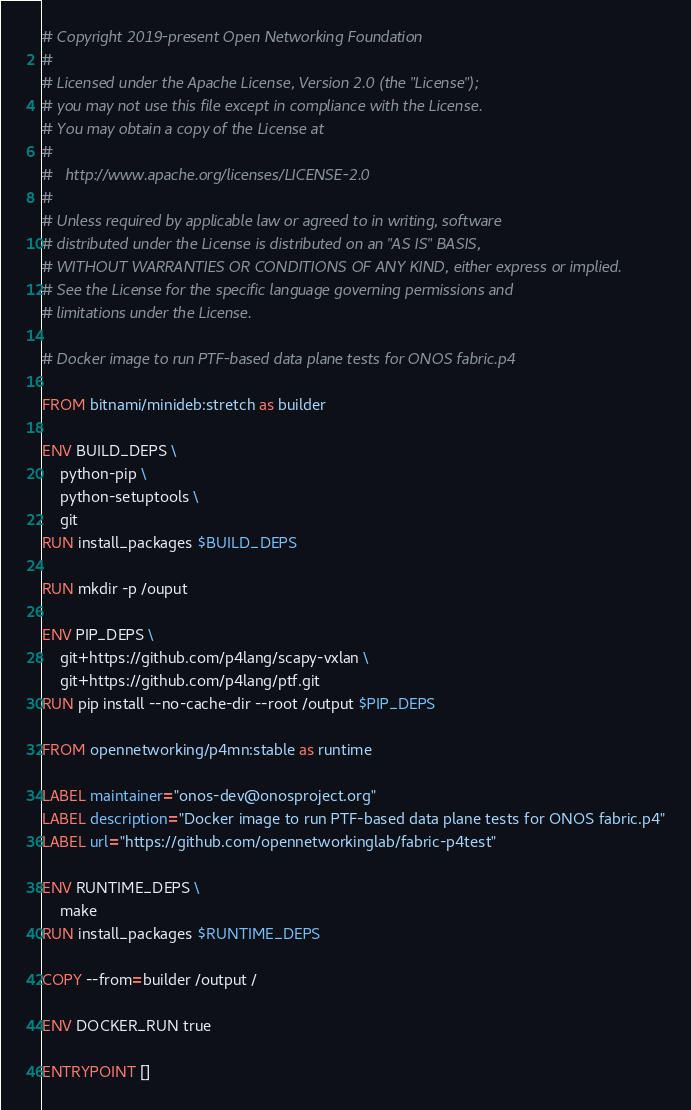Convert code to text. <code><loc_0><loc_0><loc_500><loc_500><_Dockerfile_># Copyright 2019-present Open Networking Foundation
#
# Licensed under the Apache License, Version 2.0 (the "License");
# you may not use this file except in compliance with the License.
# You may obtain a copy of the License at
#
#   http://www.apache.org/licenses/LICENSE-2.0
#
# Unless required by applicable law or agreed to in writing, software
# distributed under the License is distributed on an "AS IS" BASIS,
# WITHOUT WARRANTIES OR CONDITIONS OF ANY KIND, either express or implied.
# See the License for the specific language governing permissions and
# limitations under the License.

# Docker image to run PTF-based data plane tests for ONOS fabric.p4

FROM bitnami/minideb:stretch as builder

ENV BUILD_DEPS \
    python-pip \
    python-setuptools \
    git
RUN install_packages $BUILD_DEPS

RUN mkdir -p /ouput

ENV PIP_DEPS \
    git+https://github.com/p4lang/scapy-vxlan \
    git+https://github.com/p4lang/ptf.git
RUN pip install --no-cache-dir --root /output $PIP_DEPS

FROM opennetworking/p4mn:stable as runtime

LABEL maintainer="onos-dev@onosproject.org"
LABEL description="Docker image to run PTF-based data plane tests for ONOS fabric.p4"
LABEL url="https://github.com/opennetworkinglab/fabric-p4test"

ENV RUNTIME_DEPS \
    make
RUN install_packages $RUNTIME_DEPS

COPY --from=builder /output /

ENV DOCKER_RUN true

ENTRYPOINT []</code> 